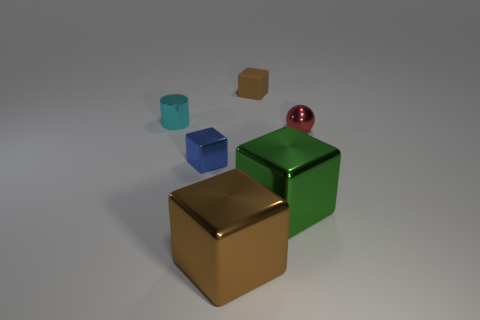Subtract all gray balls. How many brown blocks are left? 2 Add 4 large green shiny things. How many objects exist? 10 Subtract all big brown blocks. How many blocks are left? 3 Subtract 1 blocks. How many blocks are left? 3 Subtract all blue blocks. How many blocks are left? 3 Subtract all cylinders. How many objects are left? 5 Subtract all red cubes. Subtract all purple spheres. How many cubes are left? 4 Add 6 shiny blocks. How many shiny blocks are left? 9 Add 4 small shiny blocks. How many small shiny blocks exist? 5 Subtract 0 cyan spheres. How many objects are left? 6 